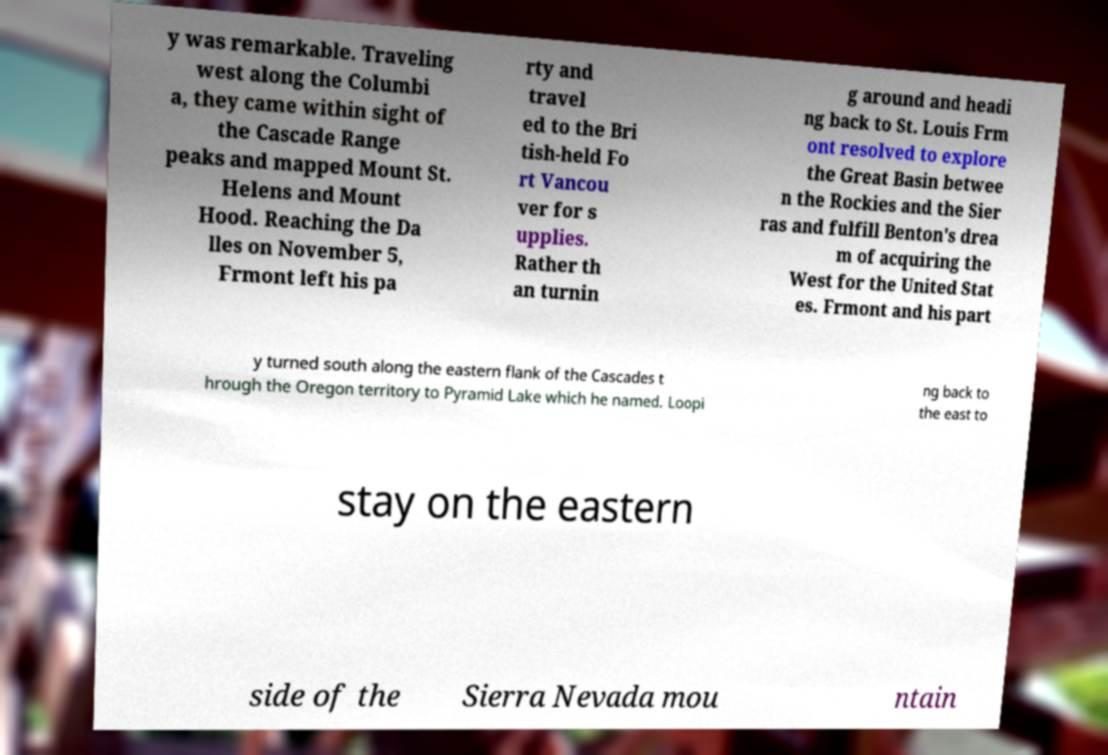There's text embedded in this image that I need extracted. Can you transcribe it verbatim? y was remarkable. Traveling west along the Columbi a, they came within sight of the Cascade Range peaks and mapped Mount St. Helens and Mount Hood. Reaching the Da lles on November 5, Frmont left his pa rty and travel ed to the Bri tish-held Fo rt Vancou ver for s upplies. Rather th an turnin g around and headi ng back to St. Louis Frm ont resolved to explore the Great Basin betwee n the Rockies and the Sier ras and fulfill Benton's drea m of acquiring the West for the United Stat es. Frmont and his part y turned south along the eastern flank of the Cascades t hrough the Oregon territory to Pyramid Lake which he named. Loopi ng back to the east to stay on the eastern side of the Sierra Nevada mou ntain 